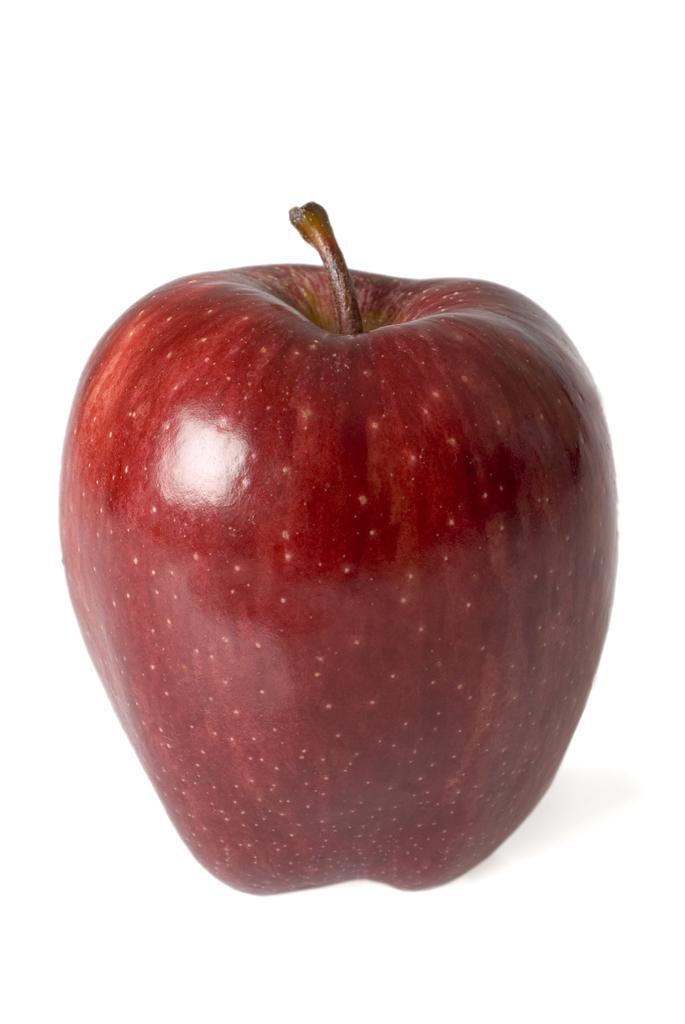Can you describe this image briefly? In this image, we can see an apple on the white background. 